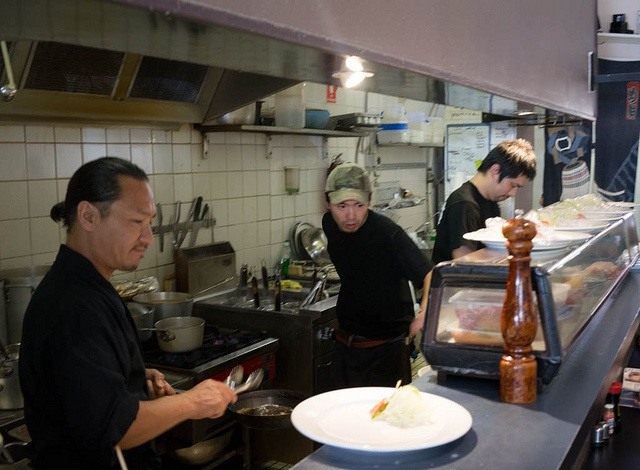Describe the objects in this image and their specific colors. I can see people in black, brown, and maroon tones, people in black and gray tones, oven in black and gray tones, people in black, gray, and tan tones, and bowl in black, gray, and darkgreen tones in this image. 